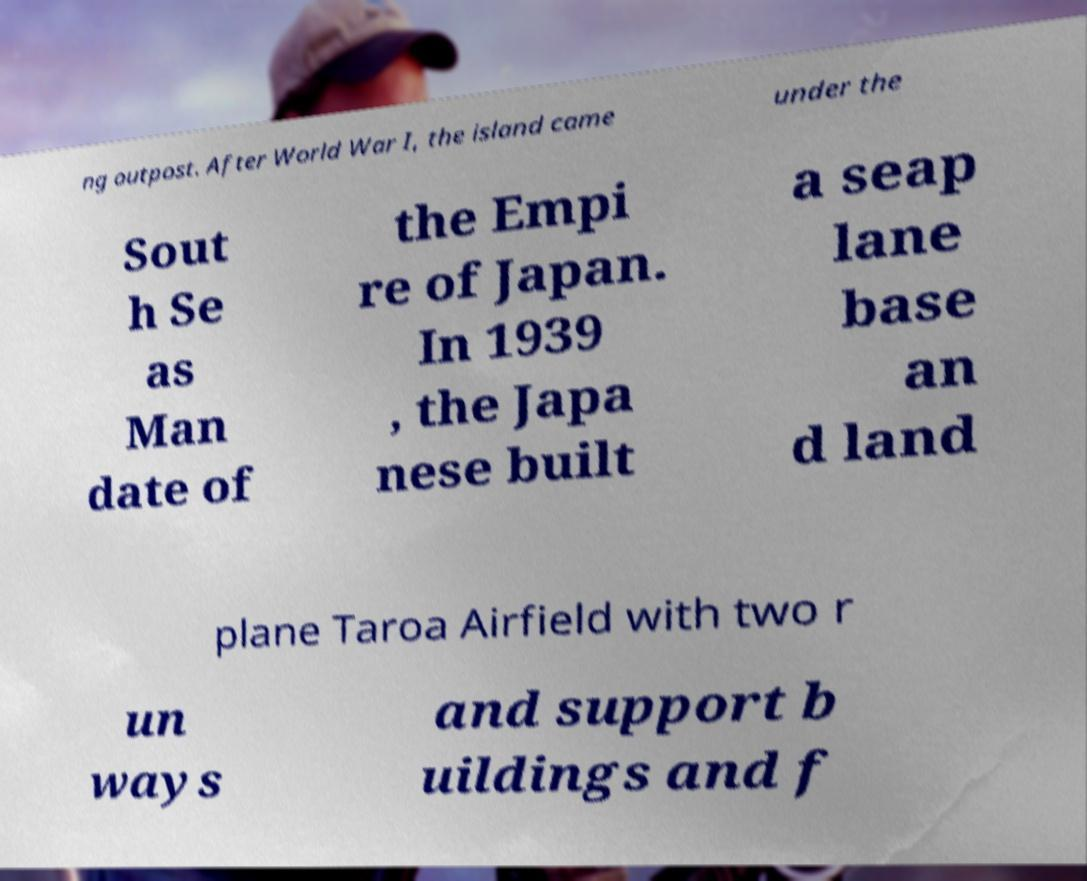I need the written content from this picture converted into text. Can you do that? ng outpost. After World War I, the island came under the Sout h Se as Man date of the Empi re of Japan. In 1939 , the Japa nese built a seap lane base an d land plane Taroa Airfield with two r un ways and support b uildings and f 